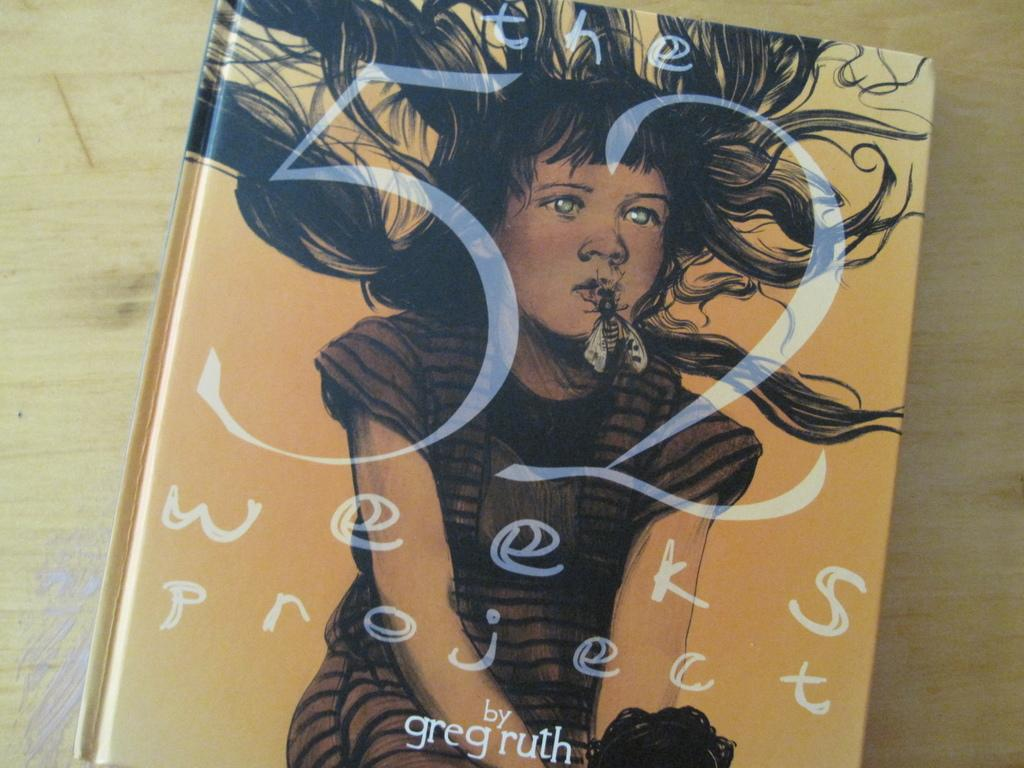What object can be seen in the image? There is a book in the image. Where is the book located? The book is placed on a wooden surface. What type of polish is being applied to the fan in the image? There is no fan or polish present in the image; it only features a book placed on a wooden surface. 